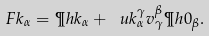Convert formula to latex. <formula><loc_0><loc_0><loc_500><loc_500>\ F { k } _ { \alpha } = \P h { k } _ { \alpha } + \ u { k } ^ { \gamma } _ { \alpha } v ^ { \beta } _ { \gamma } \P h { 0 } _ { \beta } .</formula> 